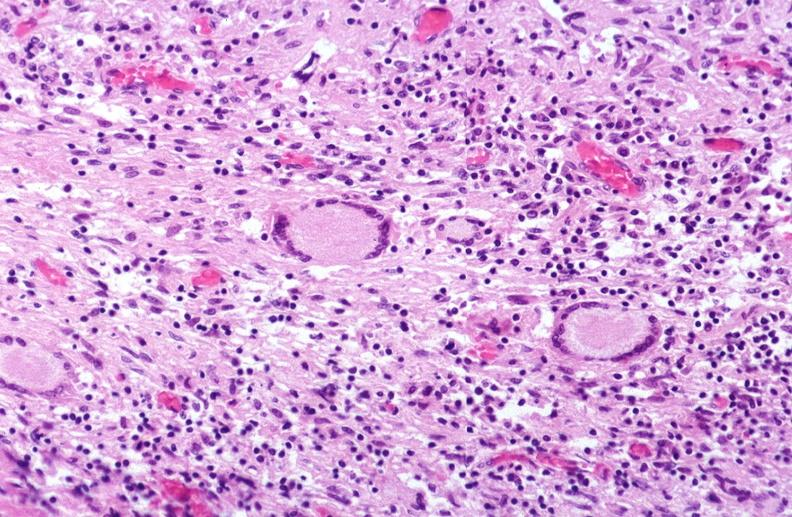s respiratory present?
Answer the question using a single word or phrase. Yes 